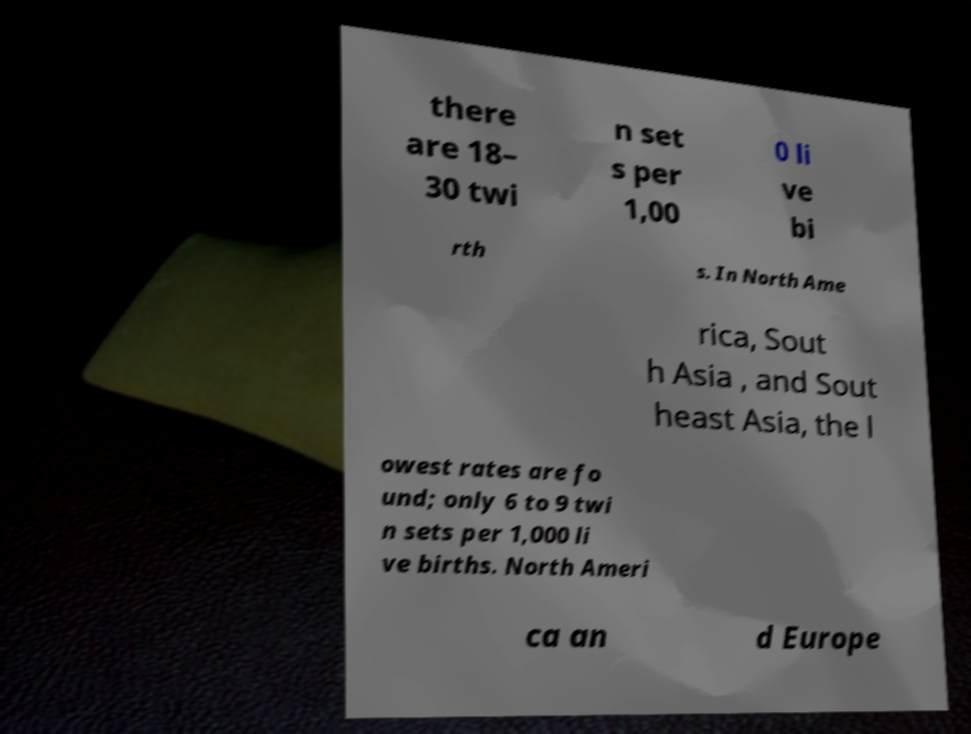Can you accurately transcribe the text from the provided image for me? there are 18– 30 twi n set s per 1,00 0 li ve bi rth s. In North Ame rica, Sout h Asia , and Sout heast Asia, the l owest rates are fo und; only 6 to 9 twi n sets per 1,000 li ve births. North Ameri ca an d Europe 